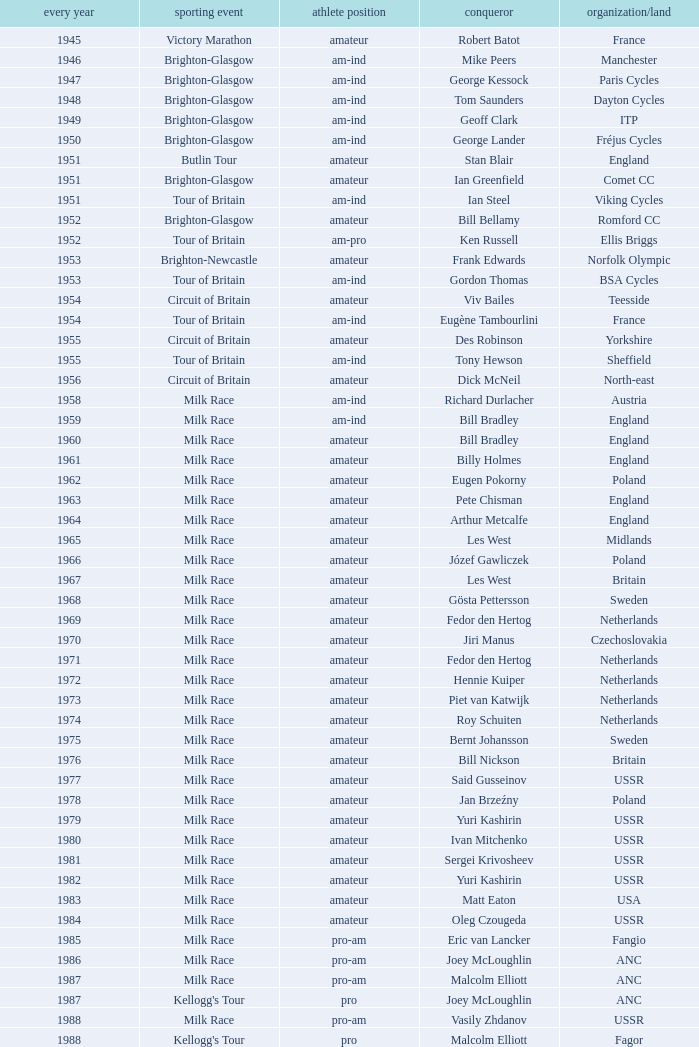Who was the winner in 1973 with an amateur rider status? Piet van Katwijk. 